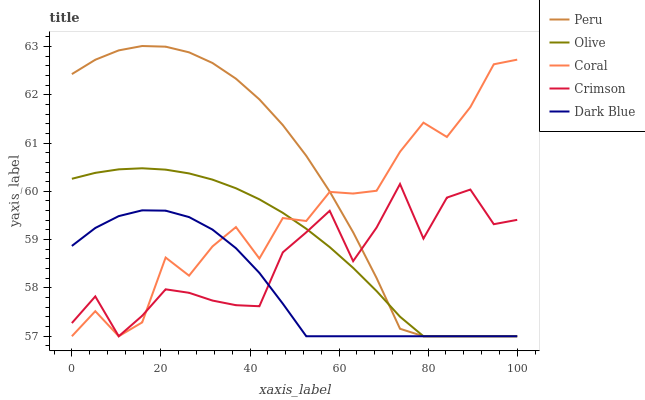Does Dark Blue have the minimum area under the curve?
Answer yes or no. Yes. Does Peru have the maximum area under the curve?
Answer yes or no. Yes. Does Crimson have the minimum area under the curve?
Answer yes or no. No. Does Crimson have the maximum area under the curve?
Answer yes or no. No. Is Olive the smoothest?
Answer yes or no. Yes. Is Crimson the roughest?
Answer yes or no. Yes. Is Coral the smoothest?
Answer yes or no. No. Is Coral the roughest?
Answer yes or no. No. Does Peru have the highest value?
Answer yes or no. Yes. Does Crimson have the highest value?
Answer yes or no. No. 